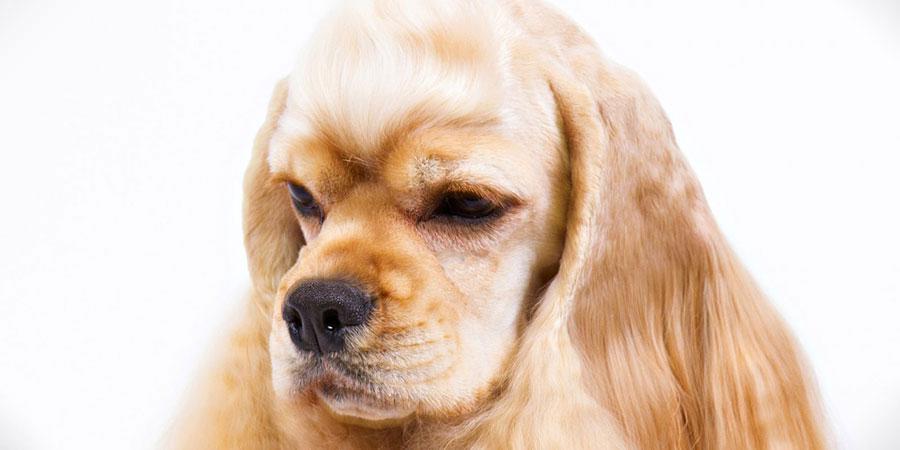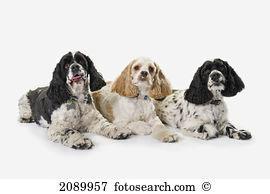The first image is the image on the left, the second image is the image on the right. Examine the images to the left and right. Is the description "Every image shoes exactly three dogs, where in one image all three dogs are blond colored and the other image they have varying colors." accurate? Answer yes or no. No. The first image is the image on the left, the second image is the image on the right. Assess this claim about the two images: "There is exactly three dogs in the left image.". Correct or not? Answer yes or no. No. 